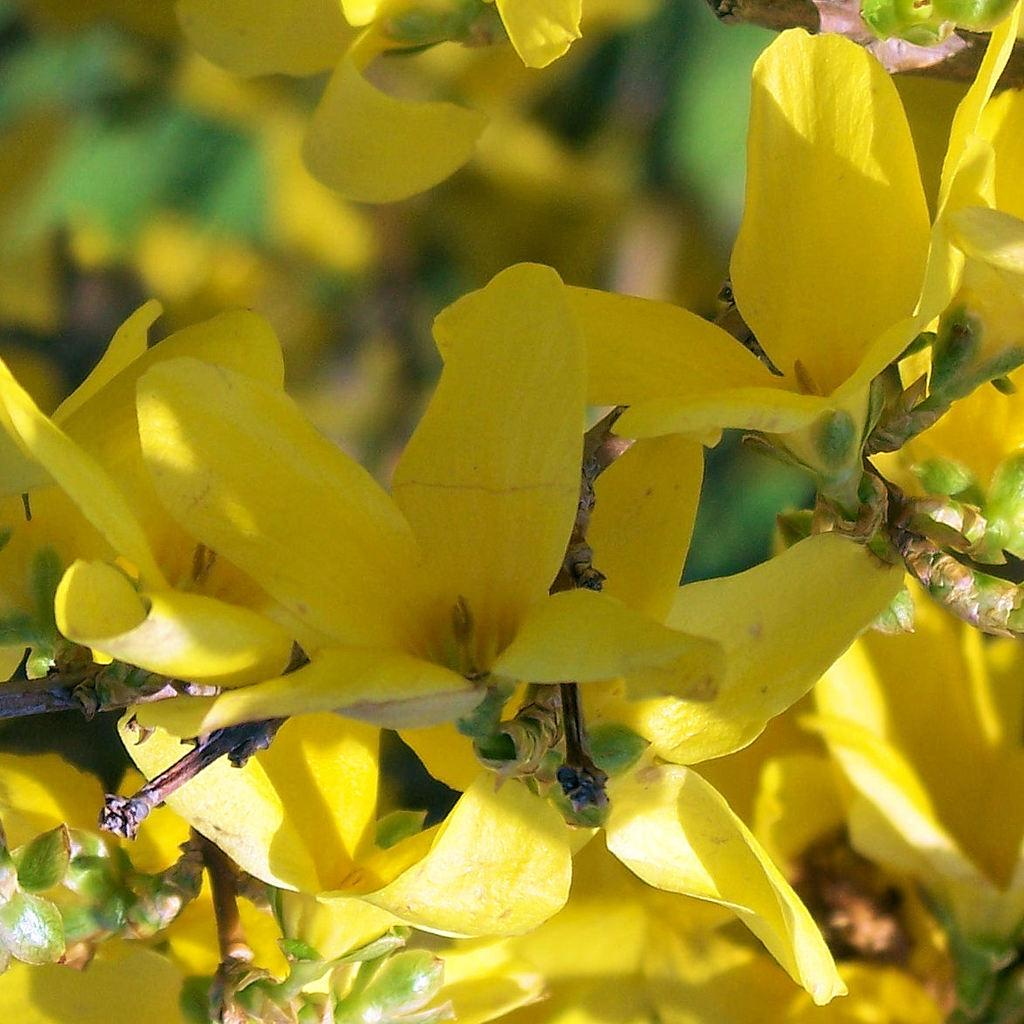What type of flowers can be seen in the image? There are yellow flowers in the image. What color are the leaves associated with the flowers? There are green leaves in the image. Can you describe the background of the image? The background of the image is blurred. Where is the nearest store to the sheep in the image? There are no sheep present in the image, and therefore no store can be associated with them. 